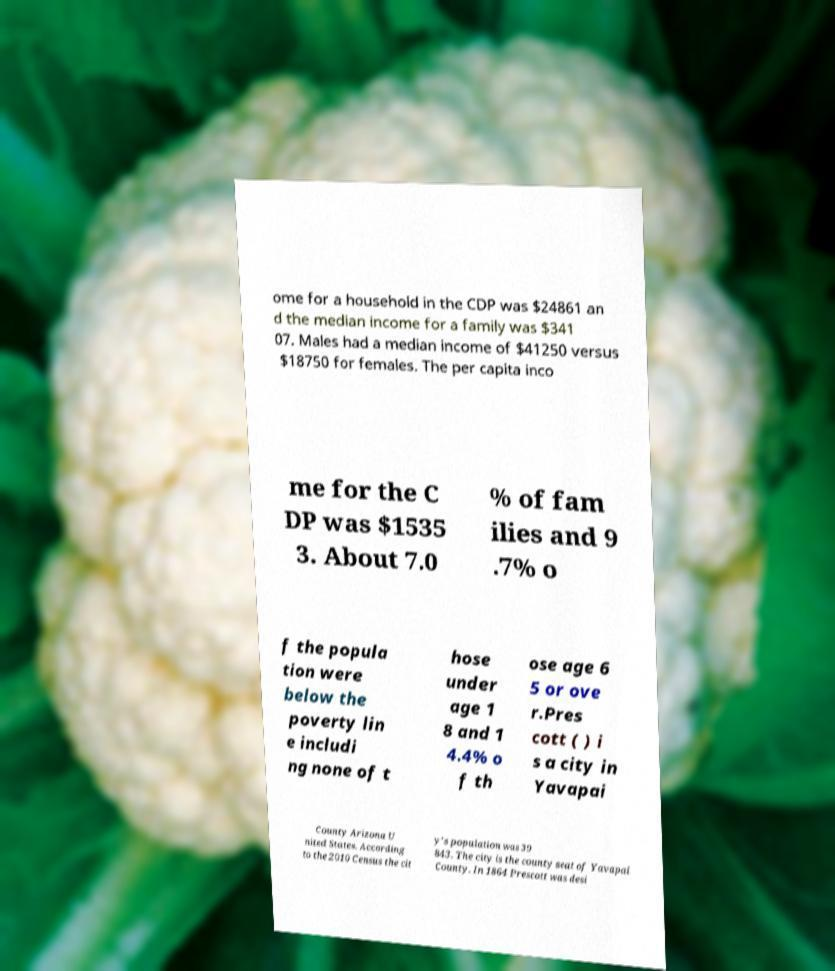There's text embedded in this image that I need extracted. Can you transcribe it verbatim? ome for a household in the CDP was $24861 an d the median income for a family was $341 07. Males had a median income of $41250 versus $18750 for females. The per capita inco me for the C DP was $1535 3. About 7.0 % of fam ilies and 9 .7% o f the popula tion were below the poverty lin e includi ng none of t hose under age 1 8 and 1 4.4% o f th ose age 6 5 or ove r.Pres cott ( ) i s a city in Yavapai County Arizona U nited States. According to the 2010 Census the cit y's population was 39 843. The city is the county seat of Yavapai County. In 1864 Prescott was desi 